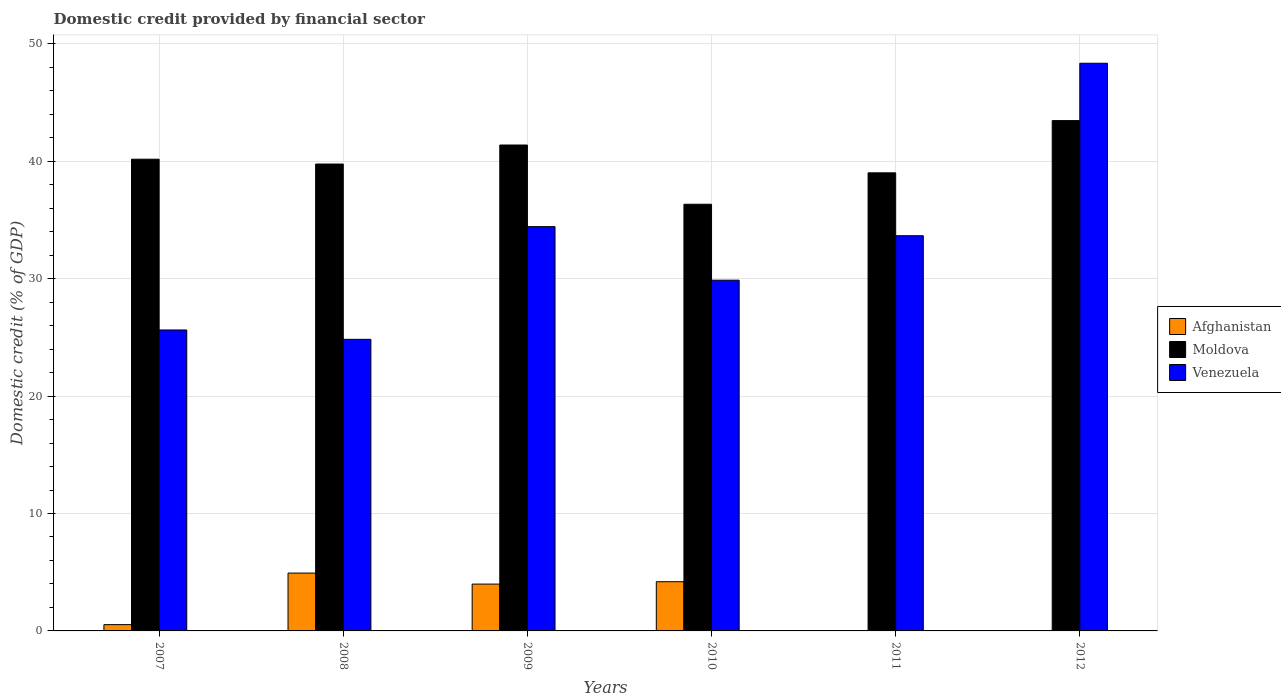How many different coloured bars are there?
Provide a succinct answer. 3. How many groups of bars are there?
Offer a very short reply. 6. Are the number of bars per tick equal to the number of legend labels?
Offer a terse response. No. Are the number of bars on each tick of the X-axis equal?
Make the answer very short. No. How many bars are there on the 1st tick from the left?
Give a very brief answer. 3. What is the domestic credit in Venezuela in 2010?
Your response must be concise. 29.87. Across all years, what is the maximum domestic credit in Moldova?
Give a very brief answer. 43.46. Across all years, what is the minimum domestic credit in Moldova?
Your answer should be compact. 36.34. In which year was the domestic credit in Venezuela maximum?
Your answer should be compact. 2012. What is the total domestic credit in Moldova in the graph?
Your answer should be very brief. 240.12. What is the difference between the domestic credit in Moldova in 2010 and that in 2012?
Offer a terse response. -7.12. What is the difference between the domestic credit in Venezuela in 2009 and the domestic credit in Afghanistan in 2012?
Provide a succinct answer. 34.43. What is the average domestic credit in Afghanistan per year?
Keep it short and to the point. 2.27. In the year 2008, what is the difference between the domestic credit in Afghanistan and domestic credit in Venezuela?
Offer a terse response. -19.91. What is the ratio of the domestic credit in Moldova in 2007 to that in 2010?
Keep it short and to the point. 1.11. What is the difference between the highest and the second highest domestic credit in Afghanistan?
Ensure brevity in your answer.  0.73. What is the difference between the highest and the lowest domestic credit in Venezuela?
Offer a very short reply. 23.51. Is it the case that in every year, the sum of the domestic credit in Venezuela and domestic credit in Afghanistan is greater than the domestic credit in Moldova?
Provide a short and direct response. No. How many years are there in the graph?
Offer a very short reply. 6. What is the difference between two consecutive major ticks on the Y-axis?
Your response must be concise. 10. Are the values on the major ticks of Y-axis written in scientific E-notation?
Offer a very short reply. No. Does the graph contain any zero values?
Offer a terse response. Yes. Does the graph contain grids?
Keep it short and to the point. Yes. How many legend labels are there?
Your answer should be compact. 3. How are the legend labels stacked?
Offer a very short reply. Vertical. What is the title of the graph?
Your answer should be compact. Domestic credit provided by financial sector. What is the label or title of the X-axis?
Offer a terse response. Years. What is the label or title of the Y-axis?
Offer a terse response. Domestic credit (% of GDP). What is the Domestic credit (% of GDP) in Afghanistan in 2007?
Keep it short and to the point. 0.54. What is the Domestic credit (% of GDP) in Moldova in 2007?
Provide a short and direct response. 40.17. What is the Domestic credit (% of GDP) in Venezuela in 2007?
Your answer should be compact. 25.63. What is the Domestic credit (% of GDP) in Afghanistan in 2008?
Give a very brief answer. 4.93. What is the Domestic credit (% of GDP) in Moldova in 2008?
Keep it short and to the point. 39.76. What is the Domestic credit (% of GDP) of Venezuela in 2008?
Your answer should be compact. 24.83. What is the Domestic credit (% of GDP) in Afghanistan in 2009?
Keep it short and to the point. 3.99. What is the Domestic credit (% of GDP) of Moldova in 2009?
Ensure brevity in your answer.  41.38. What is the Domestic credit (% of GDP) of Venezuela in 2009?
Keep it short and to the point. 34.43. What is the Domestic credit (% of GDP) in Afghanistan in 2010?
Ensure brevity in your answer.  4.19. What is the Domestic credit (% of GDP) of Moldova in 2010?
Make the answer very short. 36.34. What is the Domestic credit (% of GDP) of Venezuela in 2010?
Provide a succinct answer. 29.87. What is the Domestic credit (% of GDP) of Afghanistan in 2011?
Make the answer very short. 0. What is the Domestic credit (% of GDP) of Moldova in 2011?
Your answer should be very brief. 39.01. What is the Domestic credit (% of GDP) of Venezuela in 2011?
Keep it short and to the point. 33.66. What is the Domestic credit (% of GDP) in Moldova in 2012?
Keep it short and to the point. 43.46. What is the Domestic credit (% of GDP) in Venezuela in 2012?
Ensure brevity in your answer.  48.34. Across all years, what is the maximum Domestic credit (% of GDP) in Afghanistan?
Make the answer very short. 4.93. Across all years, what is the maximum Domestic credit (% of GDP) in Moldova?
Offer a terse response. 43.46. Across all years, what is the maximum Domestic credit (% of GDP) of Venezuela?
Your response must be concise. 48.34. Across all years, what is the minimum Domestic credit (% of GDP) in Moldova?
Your answer should be very brief. 36.34. Across all years, what is the minimum Domestic credit (% of GDP) in Venezuela?
Ensure brevity in your answer.  24.83. What is the total Domestic credit (% of GDP) in Afghanistan in the graph?
Offer a terse response. 13.64. What is the total Domestic credit (% of GDP) in Moldova in the graph?
Offer a very short reply. 240.12. What is the total Domestic credit (% of GDP) in Venezuela in the graph?
Provide a short and direct response. 196.76. What is the difference between the Domestic credit (% of GDP) in Afghanistan in 2007 and that in 2008?
Offer a terse response. -4.39. What is the difference between the Domestic credit (% of GDP) in Moldova in 2007 and that in 2008?
Keep it short and to the point. 0.41. What is the difference between the Domestic credit (% of GDP) of Venezuela in 2007 and that in 2008?
Your response must be concise. 0.8. What is the difference between the Domestic credit (% of GDP) of Afghanistan in 2007 and that in 2009?
Keep it short and to the point. -3.45. What is the difference between the Domestic credit (% of GDP) in Moldova in 2007 and that in 2009?
Give a very brief answer. -1.21. What is the difference between the Domestic credit (% of GDP) of Venezuela in 2007 and that in 2009?
Your response must be concise. -8.8. What is the difference between the Domestic credit (% of GDP) of Afghanistan in 2007 and that in 2010?
Ensure brevity in your answer.  -3.66. What is the difference between the Domestic credit (% of GDP) of Moldova in 2007 and that in 2010?
Your response must be concise. 3.83. What is the difference between the Domestic credit (% of GDP) of Venezuela in 2007 and that in 2010?
Offer a very short reply. -4.24. What is the difference between the Domestic credit (% of GDP) of Moldova in 2007 and that in 2011?
Your answer should be compact. 1.16. What is the difference between the Domestic credit (% of GDP) of Venezuela in 2007 and that in 2011?
Your answer should be very brief. -8.03. What is the difference between the Domestic credit (% of GDP) of Moldova in 2007 and that in 2012?
Make the answer very short. -3.29. What is the difference between the Domestic credit (% of GDP) of Venezuela in 2007 and that in 2012?
Ensure brevity in your answer.  -22.71. What is the difference between the Domestic credit (% of GDP) of Afghanistan in 2008 and that in 2009?
Offer a terse response. 0.94. What is the difference between the Domestic credit (% of GDP) of Moldova in 2008 and that in 2009?
Offer a terse response. -1.62. What is the difference between the Domestic credit (% of GDP) in Venezuela in 2008 and that in 2009?
Give a very brief answer. -9.6. What is the difference between the Domestic credit (% of GDP) of Afghanistan in 2008 and that in 2010?
Your answer should be compact. 0.73. What is the difference between the Domestic credit (% of GDP) of Moldova in 2008 and that in 2010?
Make the answer very short. 3.42. What is the difference between the Domestic credit (% of GDP) in Venezuela in 2008 and that in 2010?
Ensure brevity in your answer.  -5.04. What is the difference between the Domestic credit (% of GDP) of Moldova in 2008 and that in 2011?
Provide a succinct answer. 0.75. What is the difference between the Domestic credit (% of GDP) of Venezuela in 2008 and that in 2011?
Offer a very short reply. -8.82. What is the difference between the Domestic credit (% of GDP) in Moldova in 2008 and that in 2012?
Your answer should be compact. -3.7. What is the difference between the Domestic credit (% of GDP) of Venezuela in 2008 and that in 2012?
Your answer should be compact. -23.51. What is the difference between the Domestic credit (% of GDP) in Afghanistan in 2009 and that in 2010?
Offer a terse response. -0.2. What is the difference between the Domestic credit (% of GDP) of Moldova in 2009 and that in 2010?
Keep it short and to the point. 5.04. What is the difference between the Domestic credit (% of GDP) of Venezuela in 2009 and that in 2010?
Keep it short and to the point. 4.56. What is the difference between the Domestic credit (% of GDP) of Moldova in 2009 and that in 2011?
Give a very brief answer. 2.37. What is the difference between the Domestic credit (% of GDP) of Venezuela in 2009 and that in 2011?
Provide a succinct answer. 0.77. What is the difference between the Domestic credit (% of GDP) in Moldova in 2009 and that in 2012?
Offer a very short reply. -2.08. What is the difference between the Domestic credit (% of GDP) of Venezuela in 2009 and that in 2012?
Your response must be concise. -13.91. What is the difference between the Domestic credit (% of GDP) in Moldova in 2010 and that in 2011?
Your answer should be very brief. -2.68. What is the difference between the Domestic credit (% of GDP) of Venezuela in 2010 and that in 2011?
Offer a terse response. -3.79. What is the difference between the Domestic credit (% of GDP) of Moldova in 2010 and that in 2012?
Make the answer very short. -7.12. What is the difference between the Domestic credit (% of GDP) in Venezuela in 2010 and that in 2012?
Ensure brevity in your answer.  -18.47. What is the difference between the Domestic credit (% of GDP) of Moldova in 2011 and that in 2012?
Give a very brief answer. -4.45. What is the difference between the Domestic credit (% of GDP) in Venezuela in 2011 and that in 2012?
Your answer should be compact. -14.69. What is the difference between the Domestic credit (% of GDP) in Afghanistan in 2007 and the Domestic credit (% of GDP) in Moldova in 2008?
Offer a terse response. -39.23. What is the difference between the Domestic credit (% of GDP) of Afghanistan in 2007 and the Domestic credit (% of GDP) of Venezuela in 2008?
Offer a terse response. -24.3. What is the difference between the Domestic credit (% of GDP) in Moldova in 2007 and the Domestic credit (% of GDP) in Venezuela in 2008?
Ensure brevity in your answer.  15.34. What is the difference between the Domestic credit (% of GDP) in Afghanistan in 2007 and the Domestic credit (% of GDP) in Moldova in 2009?
Give a very brief answer. -40.84. What is the difference between the Domestic credit (% of GDP) of Afghanistan in 2007 and the Domestic credit (% of GDP) of Venezuela in 2009?
Your answer should be compact. -33.89. What is the difference between the Domestic credit (% of GDP) in Moldova in 2007 and the Domestic credit (% of GDP) in Venezuela in 2009?
Your answer should be compact. 5.74. What is the difference between the Domestic credit (% of GDP) in Afghanistan in 2007 and the Domestic credit (% of GDP) in Moldova in 2010?
Keep it short and to the point. -35.8. What is the difference between the Domestic credit (% of GDP) in Afghanistan in 2007 and the Domestic credit (% of GDP) in Venezuela in 2010?
Your answer should be compact. -29.33. What is the difference between the Domestic credit (% of GDP) of Moldova in 2007 and the Domestic credit (% of GDP) of Venezuela in 2010?
Ensure brevity in your answer.  10.3. What is the difference between the Domestic credit (% of GDP) in Afghanistan in 2007 and the Domestic credit (% of GDP) in Moldova in 2011?
Ensure brevity in your answer.  -38.48. What is the difference between the Domestic credit (% of GDP) in Afghanistan in 2007 and the Domestic credit (% of GDP) in Venezuela in 2011?
Offer a terse response. -33.12. What is the difference between the Domestic credit (% of GDP) of Moldova in 2007 and the Domestic credit (% of GDP) of Venezuela in 2011?
Your answer should be very brief. 6.51. What is the difference between the Domestic credit (% of GDP) of Afghanistan in 2007 and the Domestic credit (% of GDP) of Moldova in 2012?
Your response must be concise. -42.92. What is the difference between the Domestic credit (% of GDP) of Afghanistan in 2007 and the Domestic credit (% of GDP) of Venezuela in 2012?
Give a very brief answer. -47.81. What is the difference between the Domestic credit (% of GDP) of Moldova in 2007 and the Domestic credit (% of GDP) of Venezuela in 2012?
Ensure brevity in your answer.  -8.17. What is the difference between the Domestic credit (% of GDP) in Afghanistan in 2008 and the Domestic credit (% of GDP) in Moldova in 2009?
Your answer should be compact. -36.45. What is the difference between the Domestic credit (% of GDP) of Afghanistan in 2008 and the Domestic credit (% of GDP) of Venezuela in 2009?
Your answer should be very brief. -29.5. What is the difference between the Domestic credit (% of GDP) of Moldova in 2008 and the Domestic credit (% of GDP) of Venezuela in 2009?
Your answer should be compact. 5.33. What is the difference between the Domestic credit (% of GDP) of Afghanistan in 2008 and the Domestic credit (% of GDP) of Moldova in 2010?
Your response must be concise. -31.41. What is the difference between the Domestic credit (% of GDP) of Afghanistan in 2008 and the Domestic credit (% of GDP) of Venezuela in 2010?
Your response must be concise. -24.94. What is the difference between the Domestic credit (% of GDP) in Moldova in 2008 and the Domestic credit (% of GDP) in Venezuela in 2010?
Provide a succinct answer. 9.89. What is the difference between the Domestic credit (% of GDP) in Afghanistan in 2008 and the Domestic credit (% of GDP) in Moldova in 2011?
Offer a terse response. -34.09. What is the difference between the Domestic credit (% of GDP) of Afghanistan in 2008 and the Domestic credit (% of GDP) of Venezuela in 2011?
Your answer should be very brief. -28.73. What is the difference between the Domestic credit (% of GDP) in Moldova in 2008 and the Domestic credit (% of GDP) in Venezuela in 2011?
Offer a very short reply. 6.1. What is the difference between the Domestic credit (% of GDP) in Afghanistan in 2008 and the Domestic credit (% of GDP) in Moldova in 2012?
Provide a succinct answer. -38.53. What is the difference between the Domestic credit (% of GDP) in Afghanistan in 2008 and the Domestic credit (% of GDP) in Venezuela in 2012?
Make the answer very short. -43.42. What is the difference between the Domestic credit (% of GDP) in Moldova in 2008 and the Domestic credit (% of GDP) in Venezuela in 2012?
Provide a short and direct response. -8.58. What is the difference between the Domestic credit (% of GDP) of Afghanistan in 2009 and the Domestic credit (% of GDP) of Moldova in 2010?
Keep it short and to the point. -32.35. What is the difference between the Domestic credit (% of GDP) of Afghanistan in 2009 and the Domestic credit (% of GDP) of Venezuela in 2010?
Provide a succinct answer. -25.88. What is the difference between the Domestic credit (% of GDP) in Moldova in 2009 and the Domestic credit (% of GDP) in Venezuela in 2010?
Your answer should be compact. 11.51. What is the difference between the Domestic credit (% of GDP) in Afghanistan in 2009 and the Domestic credit (% of GDP) in Moldova in 2011?
Offer a terse response. -35.02. What is the difference between the Domestic credit (% of GDP) in Afghanistan in 2009 and the Domestic credit (% of GDP) in Venezuela in 2011?
Ensure brevity in your answer.  -29.67. What is the difference between the Domestic credit (% of GDP) in Moldova in 2009 and the Domestic credit (% of GDP) in Venezuela in 2011?
Your answer should be compact. 7.72. What is the difference between the Domestic credit (% of GDP) of Afghanistan in 2009 and the Domestic credit (% of GDP) of Moldova in 2012?
Ensure brevity in your answer.  -39.47. What is the difference between the Domestic credit (% of GDP) of Afghanistan in 2009 and the Domestic credit (% of GDP) of Venezuela in 2012?
Your response must be concise. -44.35. What is the difference between the Domestic credit (% of GDP) in Moldova in 2009 and the Domestic credit (% of GDP) in Venezuela in 2012?
Give a very brief answer. -6.96. What is the difference between the Domestic credit (% of GDP) in Afghanistan in 2010 and the Domestic credit (% of GDP) in Moldova in 2011?
Your answer should be compact. -34.82. What is the difference between the Domestic credit (% of GDP) in Afghanistan in 2010 and the Domestic credit (% of GDP) in Venezuela in 2011?
Make the answer very short. -29.46. What is the difference between the Domestic credit (% of GDP) in Moldova in 2010 and the Domestic credit (% of GDP) in Venezuela in 2011?
Give a very brief answer. 2.68. What is the difference between the Domestic credit (% of GDP) in Afghanistan in 2010 and the Domestic credit (% of GDP) in Moldova in 2012?
Keep it short and to the point. -39.27. What is the difference between the Domestic credit (% of GDP) in Afghanistan in 2010 and the Domestic credit (% of GDP) in Venezuela in 2012?
Your response must be concise. -44.15. What is the difference between the Domestic credit (% of GDP) in Moldova in 2010 and the Domestic credit (% of GDP) in Venezuela in 2012?
Give a very brief answer. -12.01. What is the difference between the Domestic credit (% of GDP) of Moldova in 2011 and the Domestic credit (% of GDP) of Venezuela in 2012?
Give a very brief answer. -9.33. What is the average Domestic credit (% of GDP) in Afghanistan per year?
Give a very brief answer. 2.27. What is the average Domestic credit (% of GDP) of Moldova per year?
Give a very brief answer. 40.02. What is the average Domestic credit (% of GDP) in Venezuela per year?
Offer a very short reply. 32.79. In the year 2007, what is the difference between the Domestic credit (% of GDP) of Afghanistan and Domestic credit (% of GDP) of Moldova?
Offer a terse response. -39.64. In the year 2007, what is the difference between the Domestic credit (% of GDP) in Afghanistan and Domestic credit (% of GDP) in Venezuela?
Your answer should be compact. -25.09. In the year 2007, what is the difference between the Domestic credit (% of GDP) in Moldova and Domestic credit (% of GDP) in Venezuela?
Ensure brevity in your answer.  14.54. In the year 2008, what is the difference between the Domestic credit (% of GDP) of Afghanistan and Domestic credit (% of GDP) of Moldova?
Give a very brief answer. -34.84. In the year 2008, what is the difference between the Domestic credit (% of GDP) in Afghanistan and Domestic credit (% of GDP) in Venezuela?
Your response must be concise. -19.91. In the year 2008, what is the difference between the Domestic credit (% of GDP) in Moldova and Domestic credit (% of GDP) in Venezuela?
Keep it short and to the point. 14.93. In the year 2009, what is the difference between the Domestic credit (% of GDP) in Afghanistan and Domestic credit (% of GDP) in Moldova?
Make the answer very short. -37.39. In the year 2009, what is the difference between the Domestic credit (% of GDP) in Afghanistan and Domestic credit (% of GDP) in Venezuela?
Give a very brief answer. -30.44. In the year 2009, what is the difference between the Domestic credit (% of GDP) in Moldova and Domestic credit (% of GDP) in Venezuela?
Keep it short and to the point. 6.95. In the year 2010, what is the difference between the Domestic credit (% of GDP) of Afghanistan and Domestic credit (% of GDP) of Moldova?
Your answer should be compact. -32.14. In the year 2010, what is the difference between the Domestic credit (% of GDP) in Afghanistan and Domestic credit (% of GDP) in Venezuela?
Ensure brevity in your answer.  -25.68. In the year 2010, what is the difference between the Domestic credit (% of GDP) in Moldova and Domestic credit (% of GDP) in Venezuela?
Your response must be concise. 6.47. In the year 2011, what is the difference between the Domestic credit (% of GDP) of Moldova and Domestic credit (% of GDP) of Venezuela?
Provide a succinct answer. 5.36. In the year 2012, what is the difference between the Domestic credit (% of GDP) in Moldova and Domestic credit (% of GDP) in Venezuela?
Give a very brief answer. -4.88. What is the ratio of the Domestic credit (% of GDP) in Afghanistan in 2007 to that in 2008?
Offer a terse response. 0.11. What is the ratio of the Domestic credit (% of GDP) of Moldova in 2007 to that in 2008?
Keep it short and to the point. 1.01. What is the ratio of the Domestic credit (% of GDP) in Venezuela in 2007 to that in 2008?
Give a very brief answer. 1.03. What is the ratio of the Domestic credit (% of GDP) of Afghanistan in 2007 to that in 2009?
Offer a very short reply. 0.13. What is the ratio of the Domestic credit (% of GDP) in Moldova in 2007 to that in 2009?
Keep it short and to the point. 0.97. What is the ratio of the Domestic credit (% of GDP) of Venezuela in 2007 to that in 2009?
Offer a terse response. 0.74. What is the ratio of the Domestic credit (% of GDP) in Afghanistan in 2007 to that in 2010?
Offer a very short reply. 0.13. What is the ratio of the Domestic credit (% of GDP) in Moldova in 2007 to that in 2010?
Provide a succinct answer. 1.11. What is the ratio of the Domestic credit (% of GDP) of Venezuela in 2007 to that in 2010?
Ensure brevity in your answer.  0.86. What is the ratio of the Domestic credit (% of GDP) in Moldova in 2007 to that in 2011?
Your answer should be very brief. 1.03. What is the ratio of the Domestic credit (% of GDP) in Venezuela in 2007 to that in 2011?
Provide a short and direct response. 0.76. What is the ratio of the Domestic credit (% of GDP) of Moldova in 2007 to that in 2012?
Offer a terse response. 0.92. What is the ratio of the Domestic credit (% of GDP) in Venezuela in 2007 to that in 2012?
Give a very brief answer. 0.53. What is the ratio of the Domestic credit (% of GDP) in Afghanistan in 2008 to that in 2009?
Offer a very short reply. 1.23. What is the ratio of the Domestic credit (% of GDP) in Moldova in 2008 to that in 2009?
Provide a short and direct response. 0.96. What is the ratio of the Domestic credit (% of GDP) of Venezuela in 2008 to that in 2009?
Offer a terse response. 0.72. What is the ratio of the Domestic credit (% of GDP) in Afghanistan in 2008 to that in 2010?
Ensure brevity in your answer.  1.18. What is the ratio of the Domestic credit (% of GDP) of Moldova in 2008 to that in 2010?
Keep it short and to the point. 1.09. What is the ratio of the Domestic credit (% of GDP) in Venezuela in 2008 to that in 2010?
Give a very brief answer. 0.83. What is the ratio of the Domestic credit (% of GDP) in Moldova in 2008 to that in 2011?
Provide a short and direct response. 1.02. What is the ratio of the Domestic credit (% of GDP) in Venezuela in 2008 to that in 2011?
Your answer should be compact. 0.74. What is the ratio of the Domestic credit (% of GDP) of Moldova in 2008 to that in 2012?
Your answer should be very brief. 0.91. What is the ratio of the Domestic credit (% of GDP) in Venezuela in 2008 to that in 2012?
Keep it short and to the point. 0.51. What is the ratio of the Domestic credit (% of GDP) in Afghanistan in 2009 to that in 2010?
Offer a very short reply. 0.95. What is the ratio of the Domestic credit (% of GDP) of Moldova in 2009 to that in 2010?
Your answer should be very brief. 1.14. What is the ratio of the Domestic credit (% of GDP) in Venezuela in 2009 to that in 2010?
Provide a short and direct response. 1.15. What is the ratio of the Domestic credit (% of GDP) in Moldova in 2009 to that in 2011?
Ensure brevity in your answer.  1.06. What is the ratio of the Domestic credit (% of GDP) in Venezuela in 2009 to that in 2011?
Ensure brevity in your answer.  1.02. What is the ratio of the Domestic credit (% of GDP) of Moldova in 2009 to that in 2012?
Keep it short and to the point. 0.95. What is the ratio of the Domestic credit (% of GDP) of Venezuela in 2009 to that in 2012?
Provide a succinct answer. 0.71. What is the ratio of the Domestic credit (% of GDP) in Moldova in 2010 to that in 2011?
Provide a short and direct response. 0.93. What is the ratio of the Domestic credit (% of GDP) of Venezuela in 2010 to that in 2011?
Offer a terse response. 0.89. What is the ratio of the Domestic credit (% of GDP) of Moldova in 2010 to that in 2012?
Your answer should be compact. 0.84. What is the ratio of the Domestic credit (% of GDP) in Venezuela in 2010 to that in 2012?
Your answer should be compact. 0.62. What is the ratio of the Domestic credit (% of GDP) in Moldova in 2011 to that in 2012?
Your answer should be compact. 0.9. What is the ratio of the Domestic credit (% of GDP) in Venezuela in 2011 to that in 2012?
Offer a very short reply. 0.7. What is the difference between the highest and the second highest Domestic credit (% of GDP) in Afghanistan?
Your response must be concise. 0.73. What is the difference between the highest and the second highest Domestic credit (% of GDP) in Moldova?
Offer a terse response. 2.08. What is the difference between the highest and the second highest Domestic credit (% of GDP) of Venezuela?
Your answer should be very brief. 13.91. What is the difference between the highest and the lowest Domestic credit (% of GDP) of Afghanistan?
Provide a succinct answer. 4.93. What is the difference between the highest and the lowest Domestic credit (% of GDP) in Moldova?
Your answer should be compact. 7.12. What is the difference between the highest and the lowest Domestic credit (% of GDP) of Venezuela?
Offer a very short reply. 23.51. 